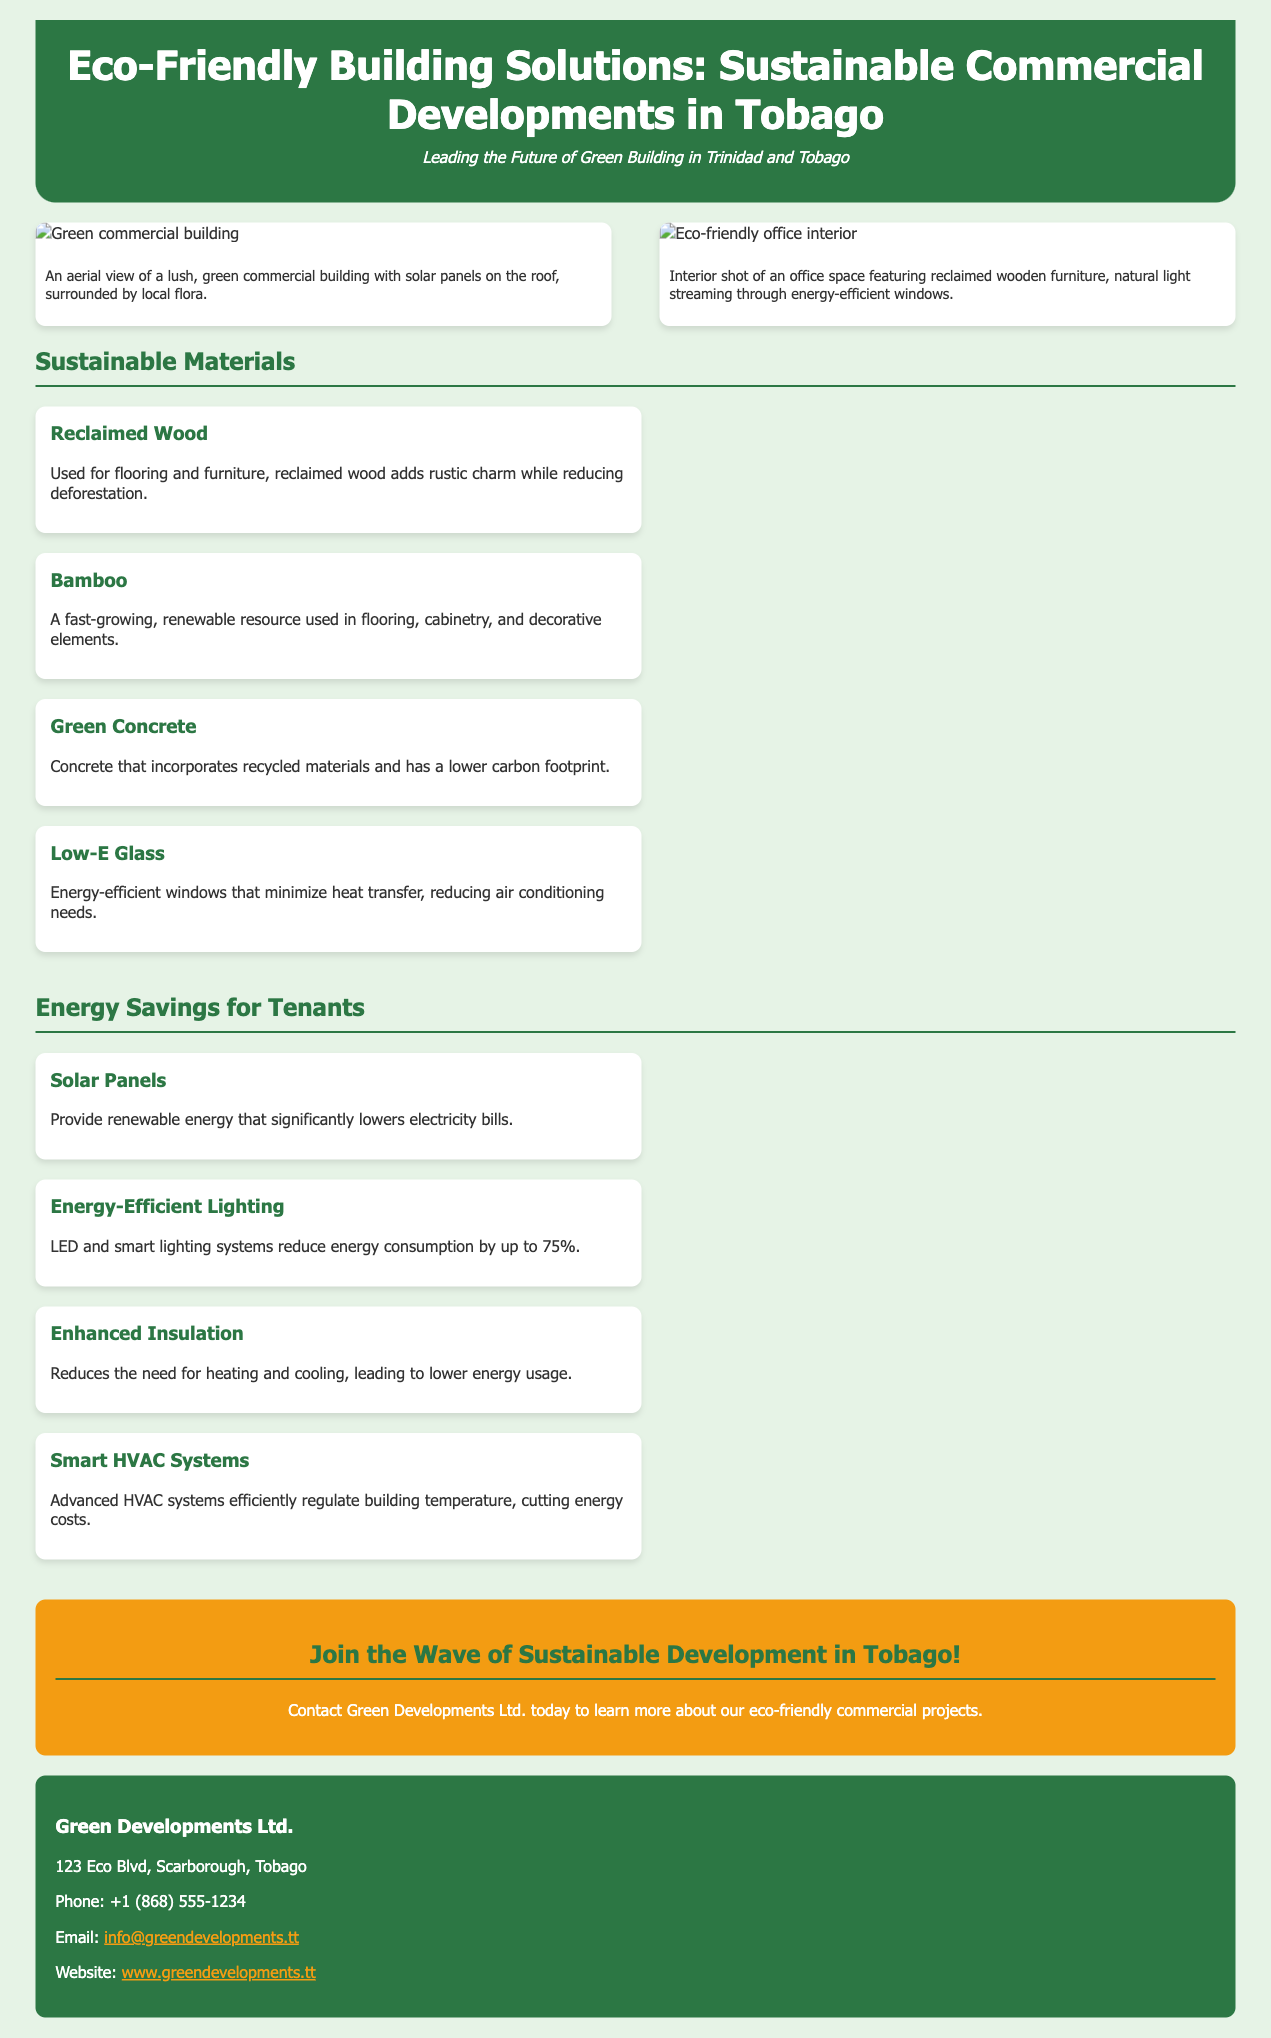what is the title of the advertisement? The title is prominently displayed at the top of the advertisement.
Answer: Eco-Friendly Building Solutions: Sustainable Commercial Developments in Tobago who is the contact person for the advertisement? The contact person is associated with the company mentioned in the contact information section.
Answer: Green Developments Ltd what is one sustainable material used for flooring? The advertisement lists various sustainable materials used in construction.
Answer: Reclaimed Wood how much can energy-efficient lighting reduce energy consumption? This figure is provided in the energy savings section of the advertisement.
Answer: up to 75% what type of glass is mentioned for energy efficiency? This detail is found in the sustainable materials section of the advertisement.
Answer: Low-E Glass which renewable energy source is utilized in the projects? This information is provided in the energy savings section regarding energy sources used.
Answer: Solar Panels what is the phone number for Green Developments Ltd.? The contact information includes a phone number for the company.
Answer: +1 (868) 555-1234 what decorative element is made from a fast-growing resource? The material section describes this renewable resource used in various applications.
Answer: Bamboo 